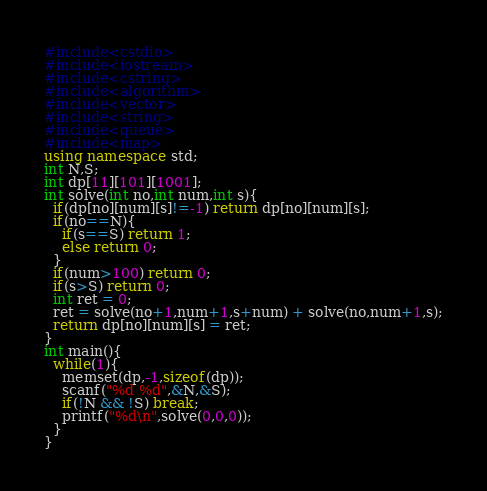Convert code to text. <code><loc_0><loc_0><loc_500><loc_500><_C++_>#include<cstdio>
#include<iostream>
#include<cstring>
#include<algorithm>
#include<vector>
#include<string>
#include<queue>
#include<map>
using namespace std;
int N,S;
int dp[11][101][1001];
int solve(int no,int num,int s){
  if(dp[no][num][s]!=-1) return dp[no][num][s];
  if(no==N){
    if(s==S) return 1;
    else return 0;
  }
  if(num>100) return 0;
  if(s>S) return 0;
  int ret = 0;
  ret = solve(no+1,num+1,s+num) + solve(no,num+1,s);
  return dp[no][num][s] = ret;
}
int main(){
  while(1){
    memset(dp,-1,sizeof(dp));
    scanf("%d %d",&N,&S);
    if(!N && !S) break;
    printf("%d\n",solve(0,0,0));
  }
}</code> 